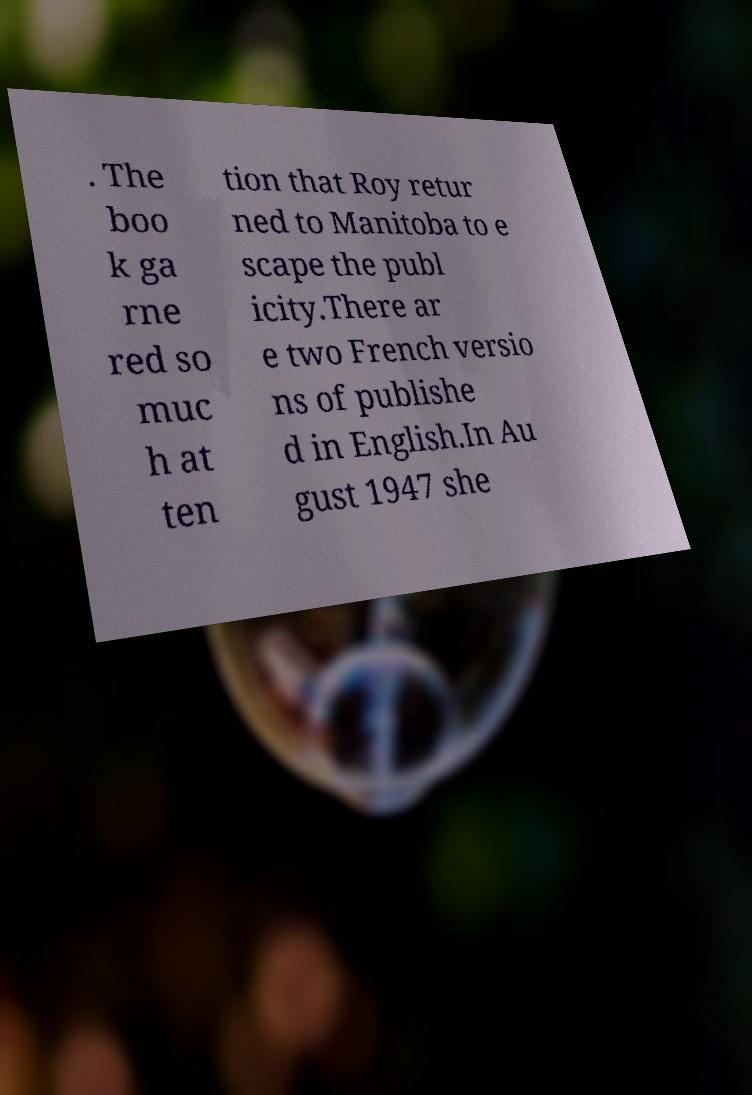Can you accurately transcribe the text from the provided image for me? . The boo k ga rne red so muc h at ten tion that Roy retur ned to Manitoba to e scape the publ icity.There ar e two French versio ns of publishe d in English.In Au gust 1947 she 